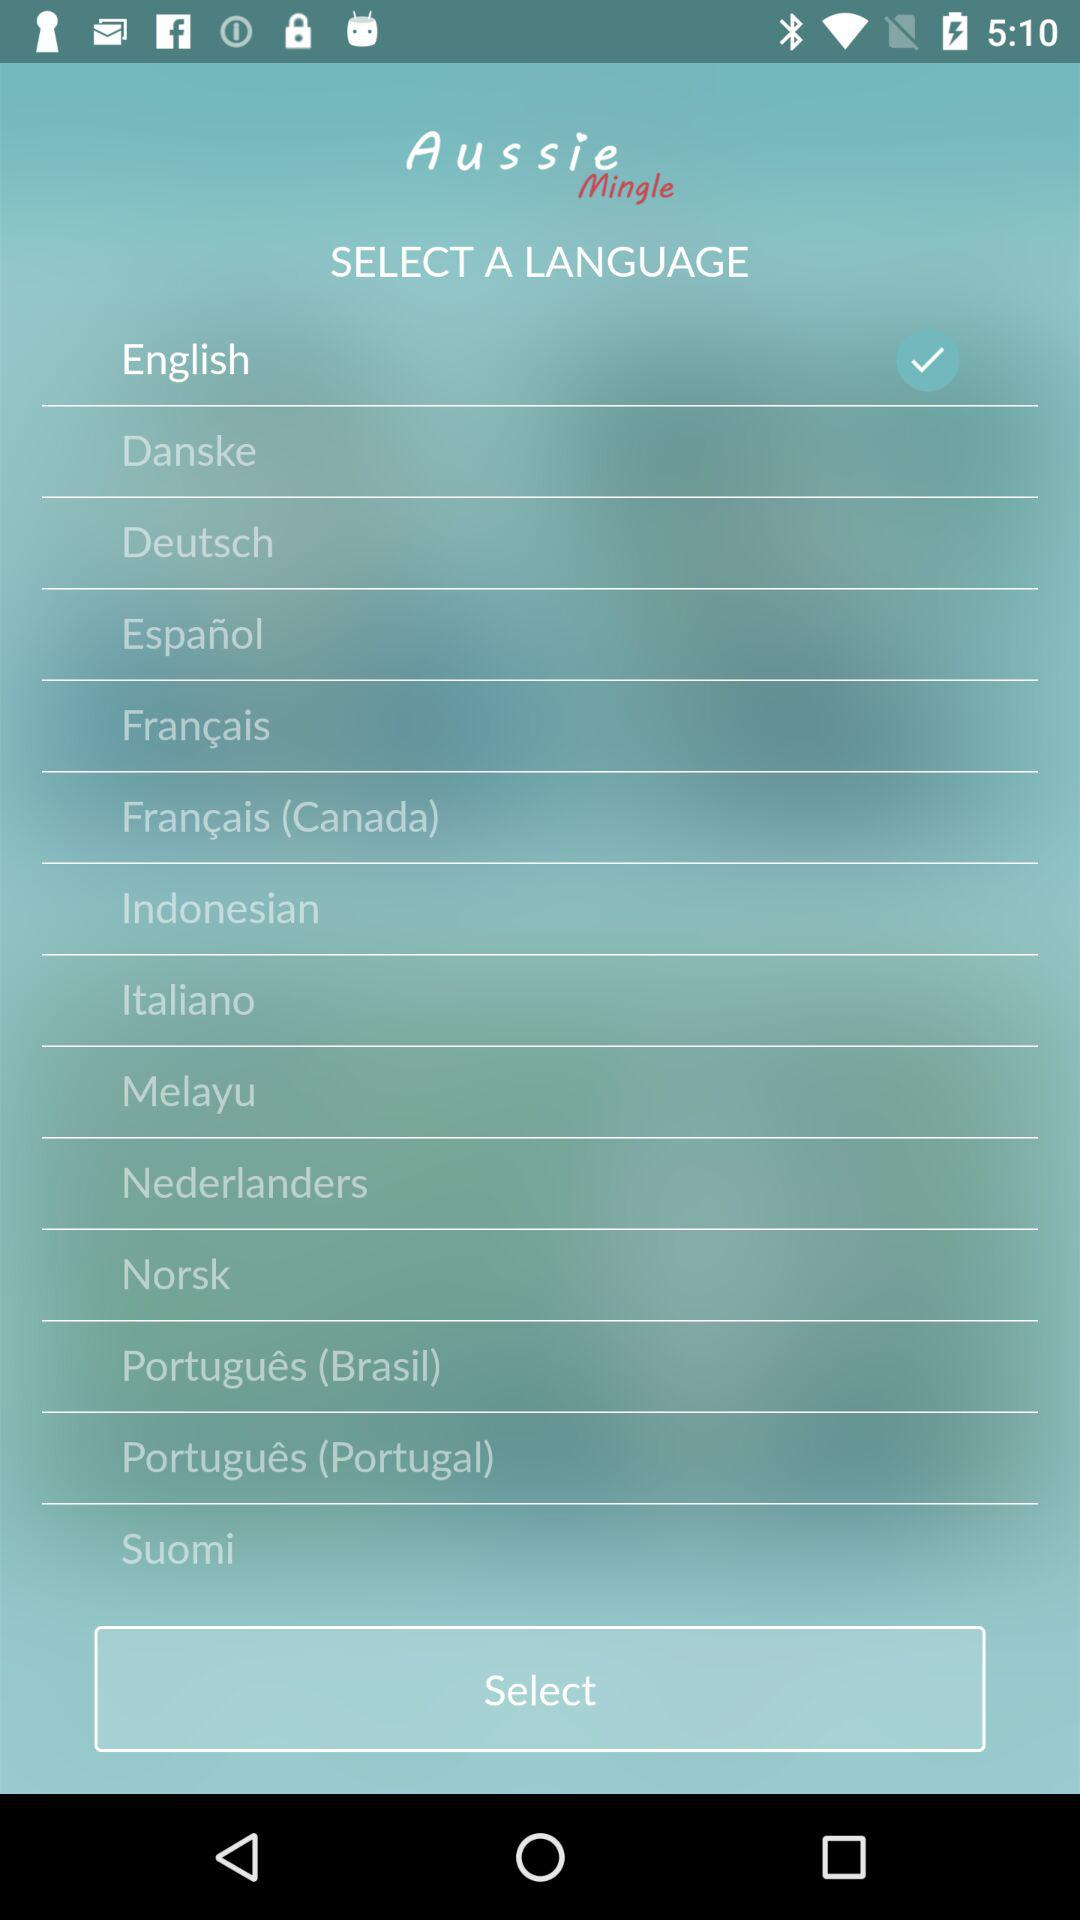In which country is Suomi spoken?
When the provided information is insufficient, respond with <no answer>. <no answer> 